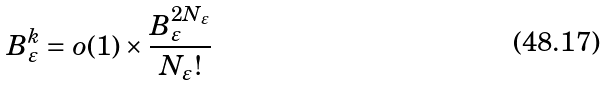Convert formula to latex. <formula><loc_0><loc_0><loc_500><loc_500>B _ { \varepsilon } ^ { k } = o ( 1 ) \times \frac { B _ { \varepsilon } ^ { 2 N _ { \varepsilon } } } { N _ { \varepsilon } ! }</formula> 